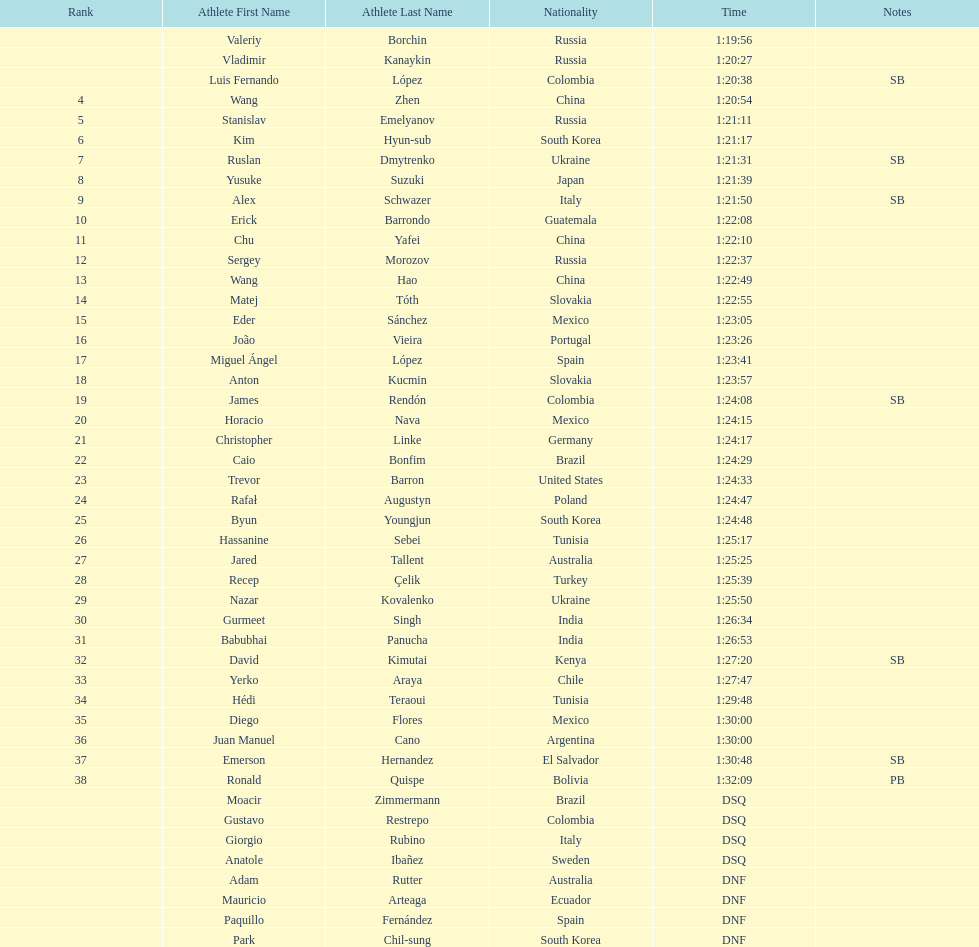Wang zhen and wang hao were both from which country? China. 